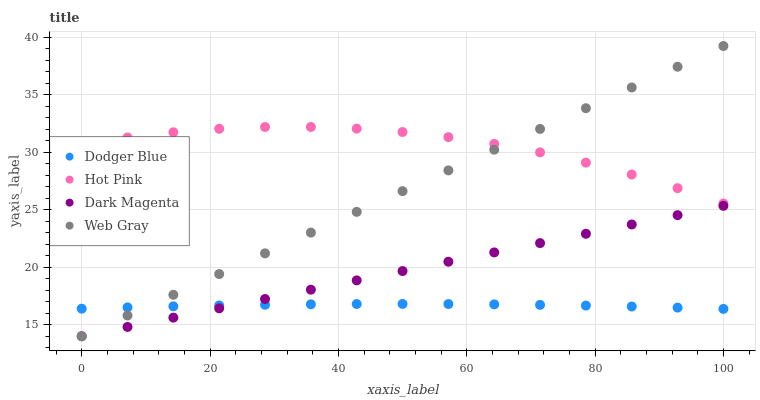Does Dodger Blue have the minimum area under the curve?
Answer yes or no. Yes. Does Hot Pink have the maximum area under the curve?
Answer yes or no. Yes. Does Hot Pink have the minimum area under the curve?
Answer yes or no. No. Does Dodger Blue have the maximum area under the curve?
Answer yes or no. No. Is Dark Magenta the smoothest?
Answer yes or no. Yes. Is Hot Pink the roughest?
Answer yes or no. Yes. Is Dodger Blue the smoothest?
Answer yes or no. No. Is Dodger Blue the roughest?
Answer yes or no. No. Does Web Gray have the lowest value?
Answer yes or no. Yes. Does Dodger Blue have the lowest value?
Answer yes or no. No. Does Web Gray have the highest value?
Answer yes or no. Yes. Does Hot Pink have the highest value?
Answer yes or no. No. Is Dodger Blue less than Hot Pink?
Answer yes or no. Yes. Is Hot Pink greater than Dark Magenta?
Answer yes or no. Yes. Does Hot Pink intersect Web Gray?
Answer yes or no. Yes. Is Hot Pink less than Web Gray?
Answer yes or no. No. Is Hot Pink greater than Web Gray?
Answer yes or no. No. Does Dodger Blue intersect Hot Pink?
Answer yes or no. No. 